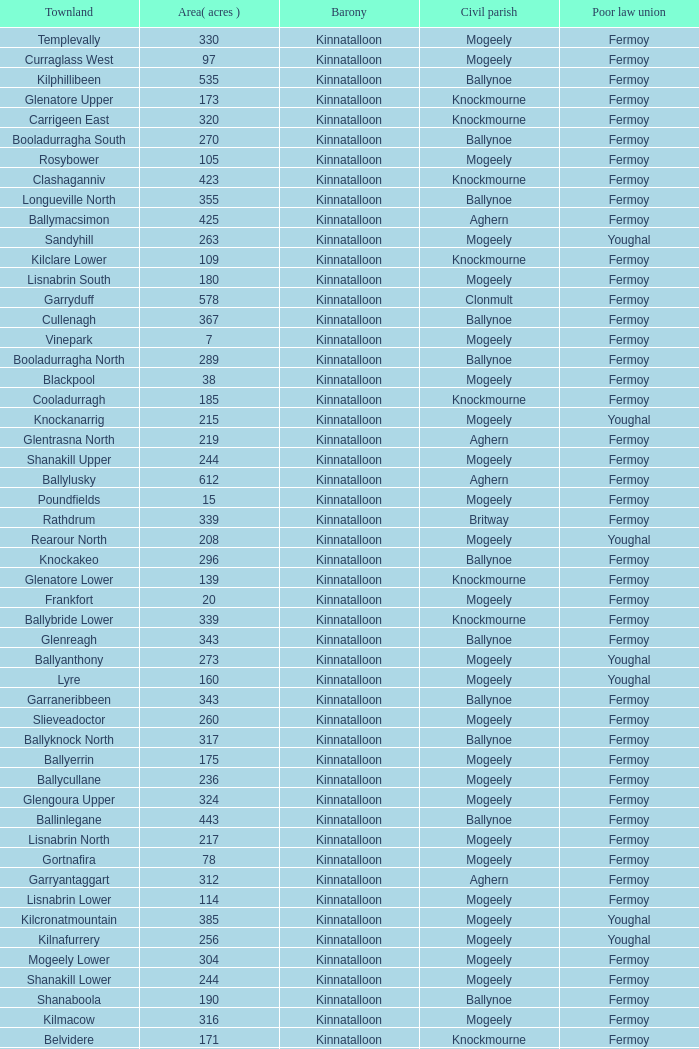Name the area for civil parish ballynoe and killasseragh 340.0. 